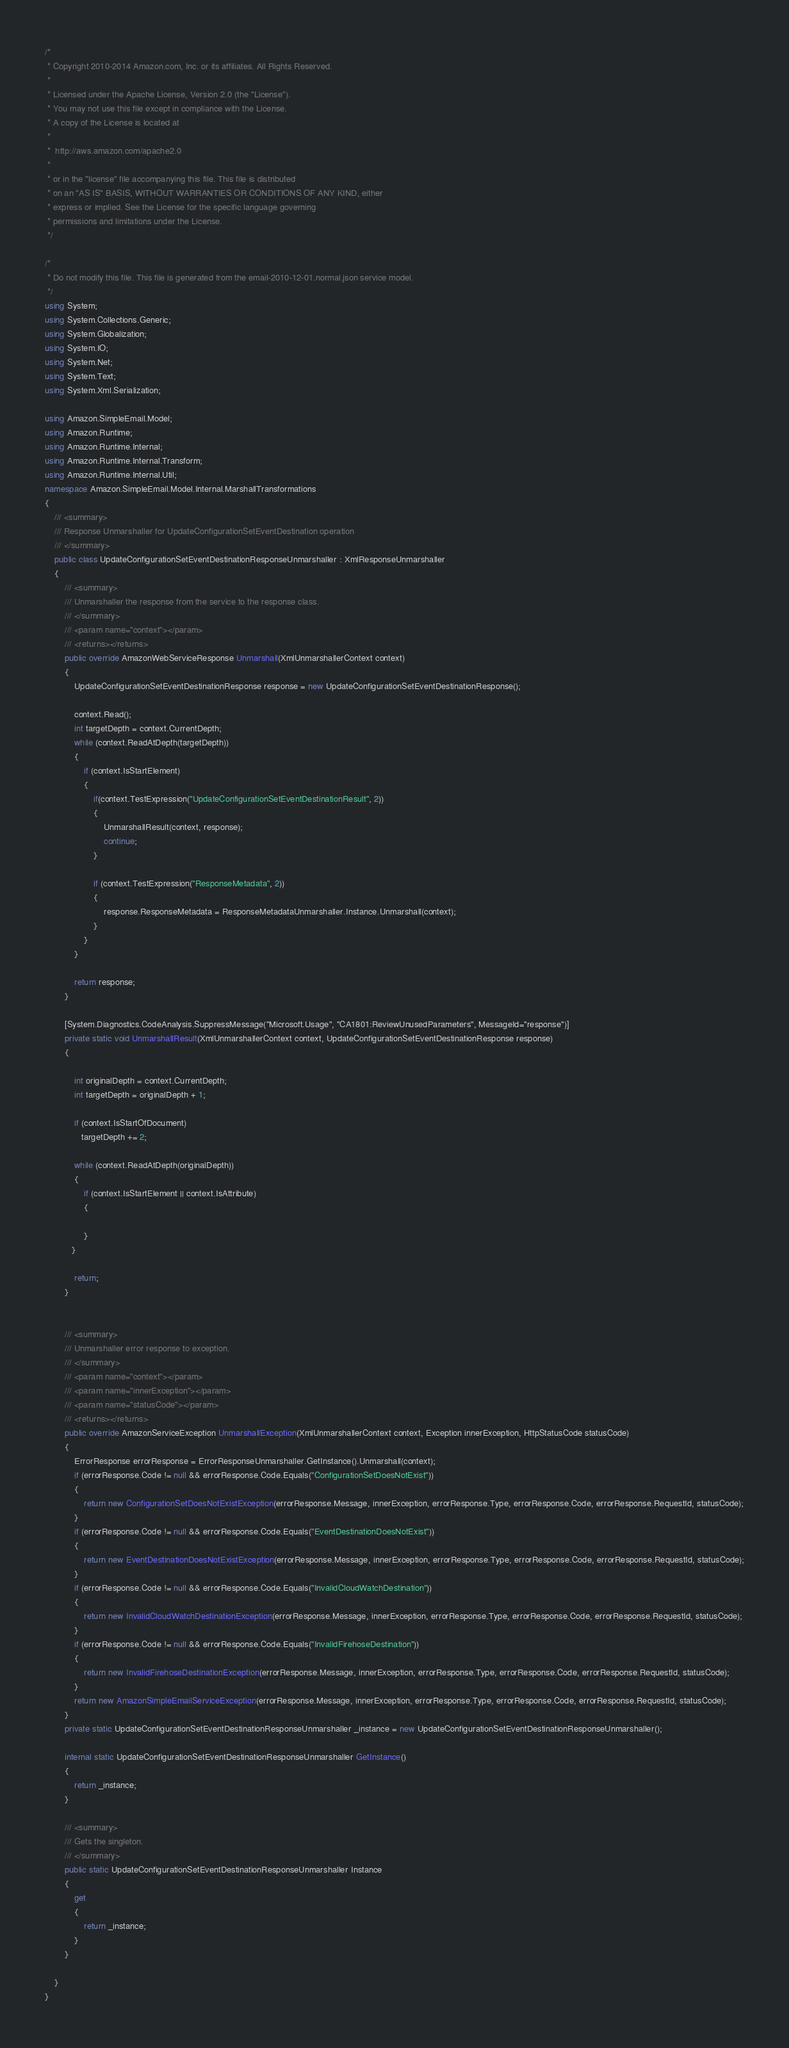<code> <loc_0><loc_0><loc_500><loc_500><_C#_>/*
 * Copyright 2010-2014 Amazon.com, Inc. or its affiliates. All Rights Reserved.
 * 
 * Licensed under the Apache License, Version 2.0 (the "License").
 * You may not use this file except in compliance with the License.
 * A copy of the License is located at
 * 
 *  http://aws.amazon.com/apache2.0
 * 
 * or in the "license" file accompanying this file. This file is distributed
 * on an "AS IS" BASIS, WITHOUT WARRANTIES OR CONDITIONS OF ANY KIND, either
 * express or implied. See the License for the specific language governing
 * permissions and limitations under the License.
 */

/*
 * Do not modify this file. This file is generated from the email-2010-12-01.normal.json service model.
 */
using System;
using System.Collections.Generic;
using System.Globalization;
using System.IO;
using System.Net;
using System.Text;
using System.Xml.Serialization;

using Amazon.SimpleEmail.Model;
using Amazon.Runtime;
using Amazon.Runtime.Internal;
using Amazon.Runtime.Internal.Transform;
using Amazon.Runtime.Internal.Util;
namespace Amazon.SimpleEmail.Model.Internal.MarshallTransformations
{
    /// <summary>
    /// Response Unmarshaller for UpdateConfigurationSetEventDestination operation
    /// </summary>  
    public class UpdateConfigurationSetEventDestinationResponseUnmarshaller : XmlResponseUnmarshaller
    {
        /// <summary>
        /// Unmarshaller the response from the service to the response class.
        /// </summary>  
        /// <param name="context"></param>
        /// <returns></returns>
        public override AmazonWebServiceResponse Unmarshall(XmlUnmarshallerContext context)
        {
            UpdateConfigurationSetEventDestinationResponse response = new UpdateConfigurationSetEventDestinationResponse();

            context.Read();
            int targetDepth = context.CurrentDepth;
            while (context.ReadAtDepth(targetDepth))
            {
                if (context.IsStartElement)
                {                    
                    if(context.TestExpression("UpdateConfigurationSetEventDestinationResult", 2))
                    {
                        UnmarshallResult(context, response);                        
                        continue;
                    }
                    
                    if (context.TestExpression("ResponseMetadata", 2))
                    {
                        response.ResponseMetadata = ResponseMetadataUnmarshaller.Instance.Unmarshall(context);
                    }
                }
            }

            return response;
        }

        [System.Diagnostics.CodeAnalysis.SuppressMessage("Microsoft.Usage", "CA1801:ReviewUnusedParameters", MessageId="response")]
        private static void UnmarshallResult(XmlUnmarshallerContext context, UpdateConfigurationSetEventDestinationResponse response)
        {
            
            int originalDepth = context.CurrentDepth;
            int targetDepth = originalDepth + 1;
            
            if (context.IsStartOfDocument) 
               targetDepth += 2;
            
            while (context.ReadAtDepth(originalDepth))
            {
                if (context.IsStartElement || context.IsAttribute)
                {

                } 
           }

            return;
        }


        /// <summary>
        /// Unmarshaller error response to exception.
        /// </summary>  
        /// <param name="context"></param>
        /// <param name="innerException"></param>
        /// <param name="statusCode"></param>
        /// <returns></returns>
        public override AmazonServiceException UnmarshallException(XmlUnmarshallerContext context, Exception innerException, HttpStatusCode statusCode)
        {
            ErrorResponse errorResponse = ErrorResponseUnmarshaller.GetInstance().Unmarshall(context);
            if (errorResponse.Code != null && errorResponse.Code.Equals("ConfigurationSetDoesNotExist"))
            {
                return new ConfigurationSetDoesNotExistException(errorResponse.Message, innerException, errorResponse.Type, errorResponse.Code, errorResponse.RequestId, statusCode);
            }
            if (errorResponse.Code != null && errorResponse.Code.Equals("EventDestinationDoesNotExist"))
            {
                return new EventDestinationDoesNotExistException(errorResponse.Message, innerException, errorResponse.Type, errorResponse.Code, errorResponse.RequestId, statusCode);
            }
            if (errorResponse.Code != null && errorResponse.Code.Equals("InvalidCloudWatchDestination"))
            {
                return new InvalidCloudWatchDestinationException(errorResponse.Message, innerException, errorResponse.Type, errorResponse.Code, errorResponse.RequestId, statusCode);
            }
            if (errorResponse.Code != null && errorResponse.Code.Equals("InvalidFirehoseDestination"))
            {
                return new InvalidFirehoseDestinationException(errorResponse.Message, innerException, errorResponse.Type, errorResponse.Code, errorResponse.RequestId, statusCode);
            }
            return new AmazonSimpleEmailServiceException(errorResponse.Message, innerException, errorResponse.Type, errorResponse.Code, errorResponse.RequestId, statusCode);
        }
        private static UpdateConfigurationSetEventDestinationResponseUnmarshaller _instance = new UpdateConfigurationSetEventDestinationResponseUnmarshaller();        

        internal static UpdateConfigurationSetEventDestinationResponseUnmarshaller GetInstance()
        {
            return _instance;
        }

        /// <summary>
        /// Gets the singleton.
        /// </summary>  
        public static UpdateConfigurationSetEventDestinationResponseUnmarshaller Instance
        {
            get
            {
                return _instance;
            }
        }

    }
}</code> 